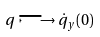Convert formula to latex. <formula><loc_0><loc_0><loc_500><loc_500>q \longmapsto \dot { q } _ { y } ( 0 )</formula> 